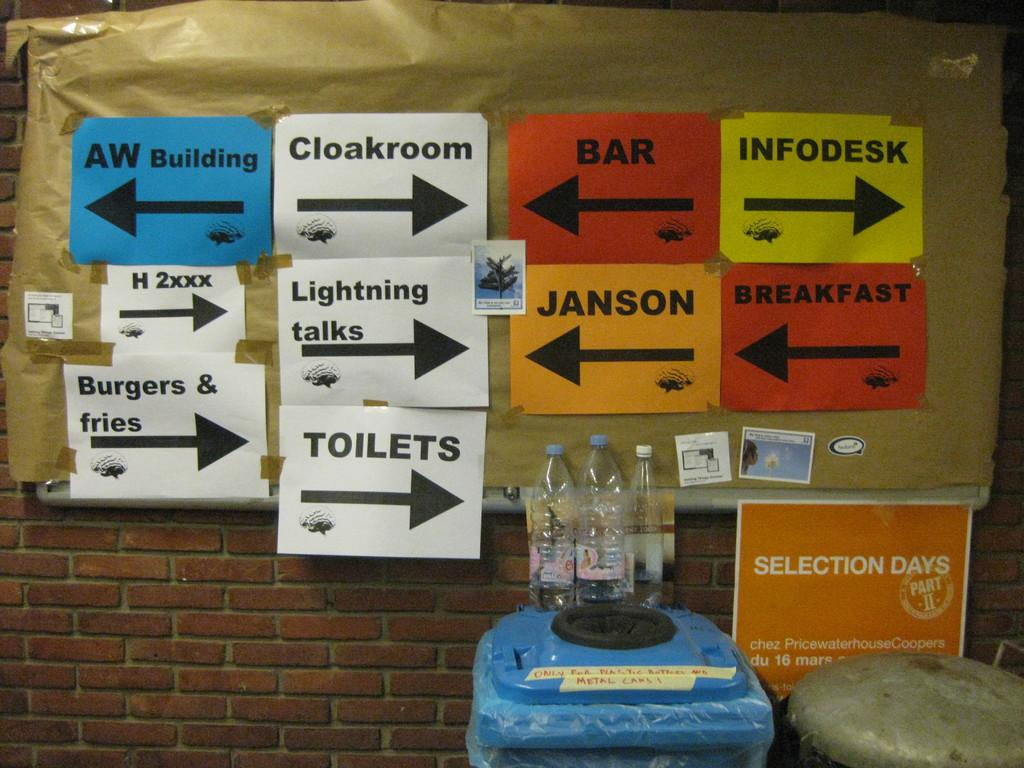What type of space is depicted in the image? There is a room in the image. What piece of furniture is present in the room? There is a table in the room. What objects are on the table? There is a bottle and a poster on the table. What can be seen in the background of the image? There are name posters visible in the background, and the wall bricks are red in color. What type of blood is visible on the poster in the image? There is no blood visible on the poster or anywhere else in the image. 